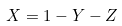Convert formula to latex. <formula><loc_0><loc_0><loc_500><loc_500>X = 1 - Y - Z</formula> 